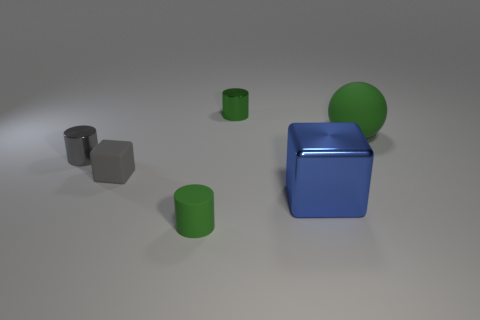There is a small thing that is in front of the small green metallic cylinder and behind the tiny block; what color is it?
Offer a very short reply. Gray. Are there more small rubber blocks that are left of the big blue metal cube than small cylinders behind the large rubber ball?
Give a very brief answer. No. What color is the tiny metallic object that is on the left side of the green matte cylinder?
Provide a short and direct response. Gray. Is the shape of the tiny metal object left of the rubber cylinder the same as the green rubber object that is to the left of the big green object?
Your answer should be compact. Yes. Is there a matte thing that has the same size as the green matte cylinder?
Make the answer very short. Yes. What is the material of the tiny green object that is behind the gray shiny cylinder?
Make the answer very short. Metal. Do the block on the right side of the matte cylinder and the small gray cube have the same material?
Ensure brevity in your answer.  No. Are any big yellow things visible?
Your answer should be compact. No. What color is the small thing that is the same material as the gray block?
Provide a succinct answer. Green. What color is the metallic cylinder left of the small green metallic cylinder that is left of the green rubber thing that is on the right side of the tiny matte cylinder?
Keep it short and to the point. Gray. 